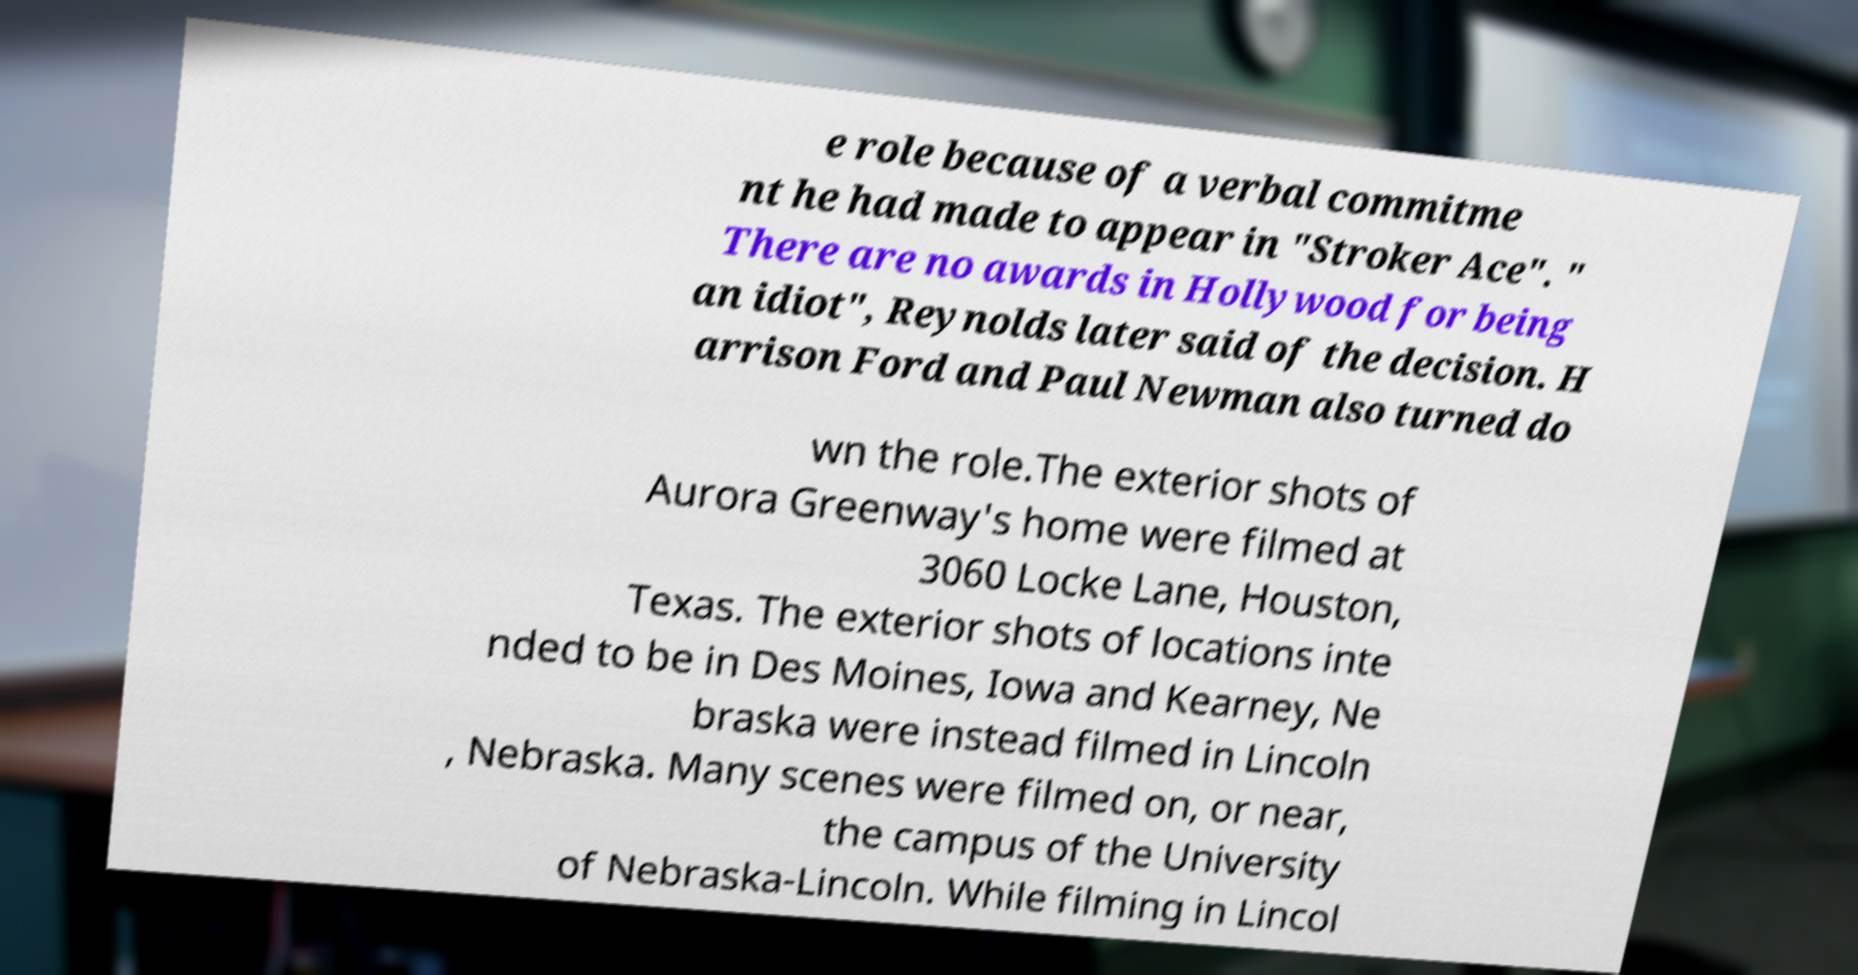Could you extract and type out the text from this image? e role because of a verbal commitme nt he had made to appear in "Stroker Ace". " There are no awards in Hollywood for being an idiot", Reynolds later said of the decision. H arrison Ford and Paul Newman also turned do wn the role.The exterior shots of Aurora Greenway's home were filmed at 3060 Locke Lane, Houston, Texas. The exterior shots of locations inte nded to be in Des Moines, Iowa and Kearney, Ne braska were instead filmed in Lincoln , Nebraska. Many scenes were filmed on, or near, the campus of the University of Nebraska-Lincoln. While filming in Lincol 